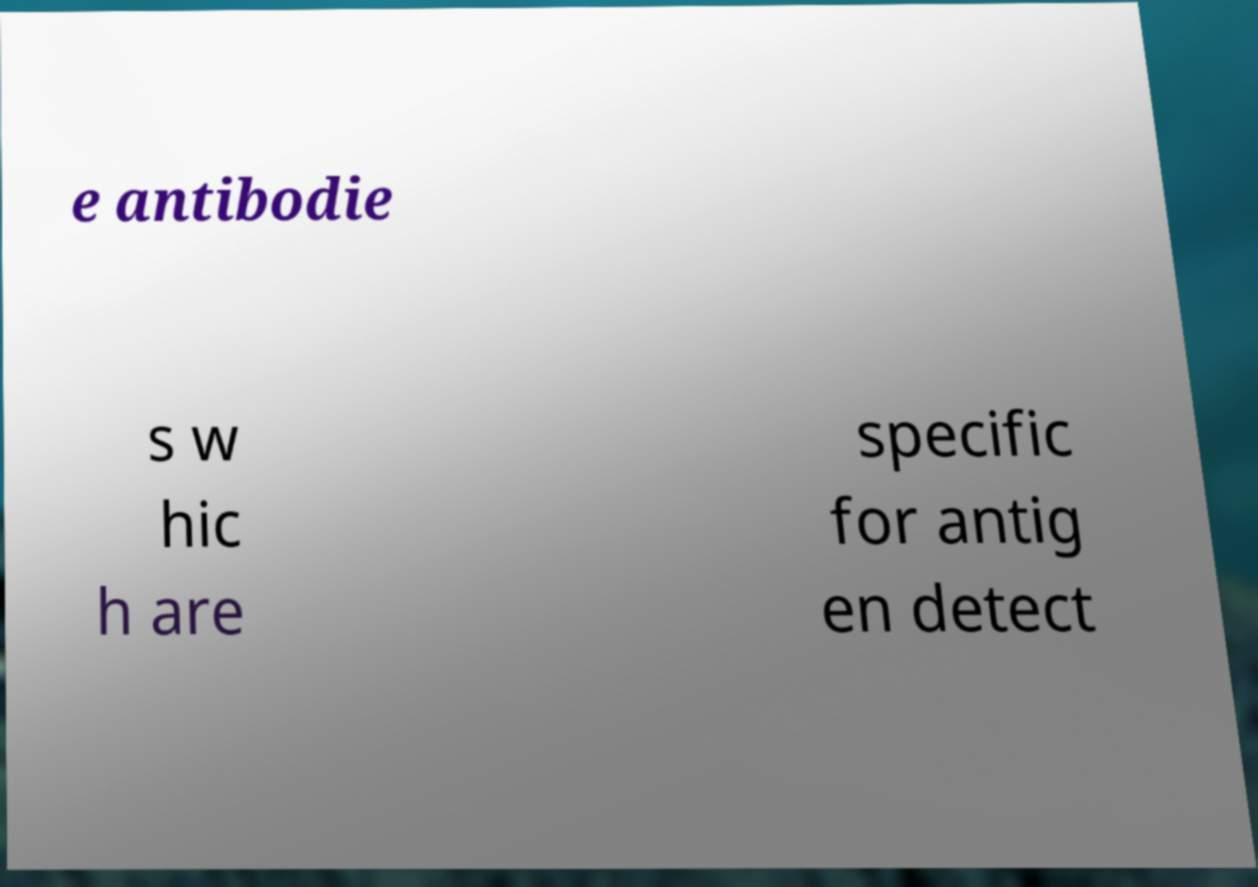Please read and relay the text visible in this image. What does it say? e antibodie s w hic h are specific for antig en detect 